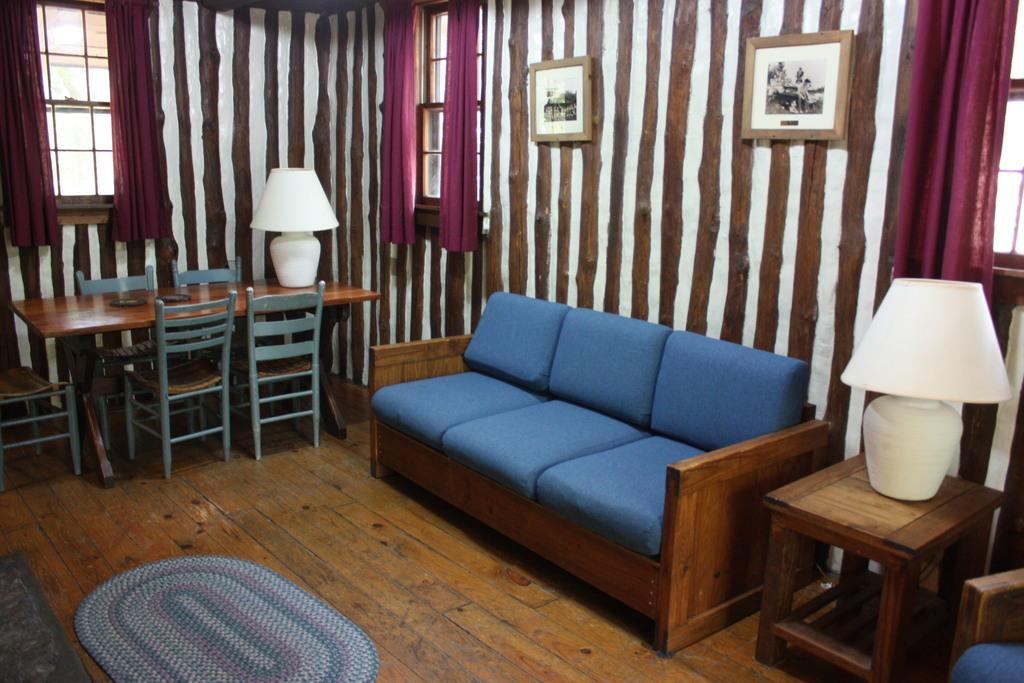What type of furniture is present in the image? There is a sofa, chairs, and a table in the image. How many lamps are visible in the image? There are two lamps in the image. What is hanging on the wall in the image? There are two frames on the wall in the image. What type of lawyer is depicted in one of the frames on the wall? There is no lawyer depicted in any of the frames on the wall in the image. 